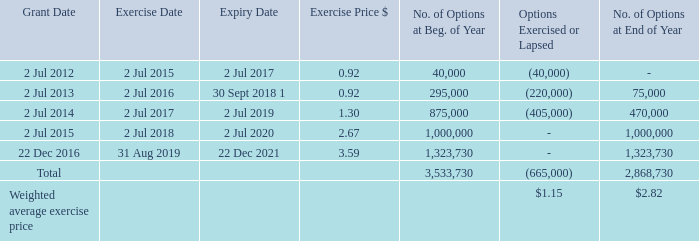Movement of options during the year ended 30 June 2018:
The weighted average fair value of options granted during the year was nil (2018: nil) as there were none issued during the year.
The weighted average share price for share options exercised during the period was $3.57 (2018: $3.90).
The weighted average remaining contractual life for share options outstanding at the end of the period was 1.68 years (2018: 2.47 years).
The weighted average remaining contractual life for share options outstanding at the end of the period was 1.68 years (2018: 2.47 years).
What was the weighted average share price for share options exercised during the period? $3.57 (2018: $3.90). What was the total weighted exercise cost for all options exercised or lapsed? 665,000 * $1.15 
Answer: 764750. What was the weighted average remaining contractual life for share options outstanding at the end of period? 1.68 years (2018: 2.47 years). Why was the weighted average fair value of options granted during the year was nil? The weighted average fair value of options granted during the year was nil (2018: nil) as there were none issued during the year. What was the total percentage change in exercise price between 2014 and 2016?
Answer scale should be: percent. (3.59 - 1.30) / 1.30 
Answer: 176.15. What was the options' exercise date with the greatest number of options exercised or lapsed? (405,000)
Answer: 2 jul 2017. 